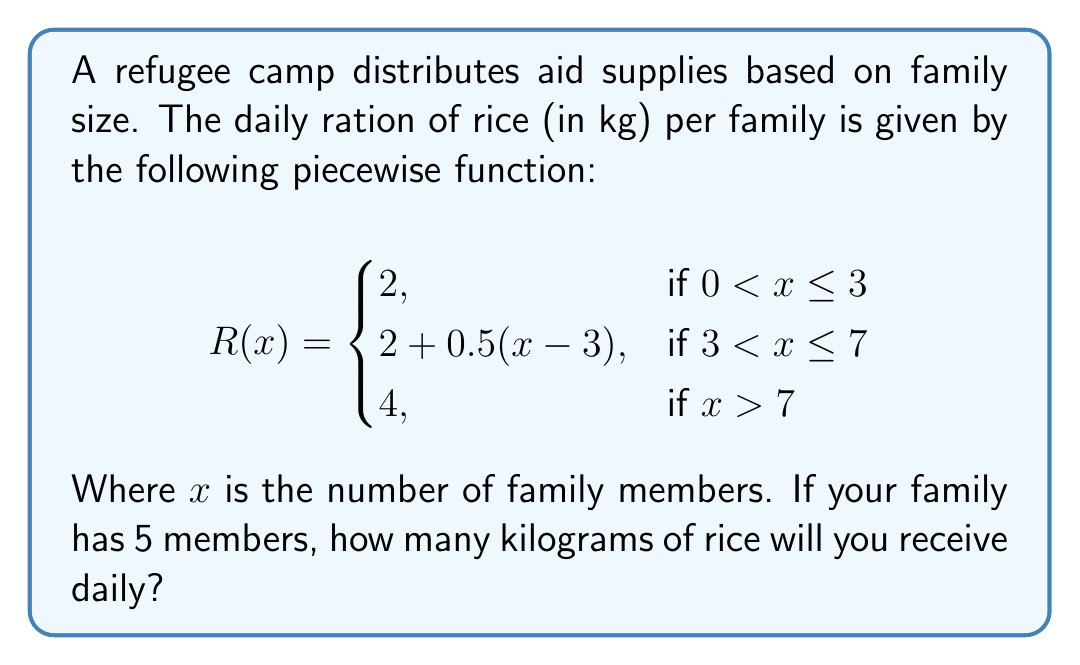Provide a solution to this math problem. To solve this problem, we need to follow these steps:

1. Identify which piece of the function applies to our situation:
   Our family size is 5 members, so we need to use the second piece of the function:
   $2 + 0.5(x-3)$ for $3 < x \leq 7$

2. Substitute $x = 5$ into the function:
   $R(5) = 2 + 0.5(5-3)$

3. Simplify the expression:
   $R(5) = 2 + 0.5(2)$
   $R(5) = 2 + 1$
   $R(5) = 3$

Therefore, a family of 5 members will receive 3 kg of rice daily.
Answer: 3 kg 